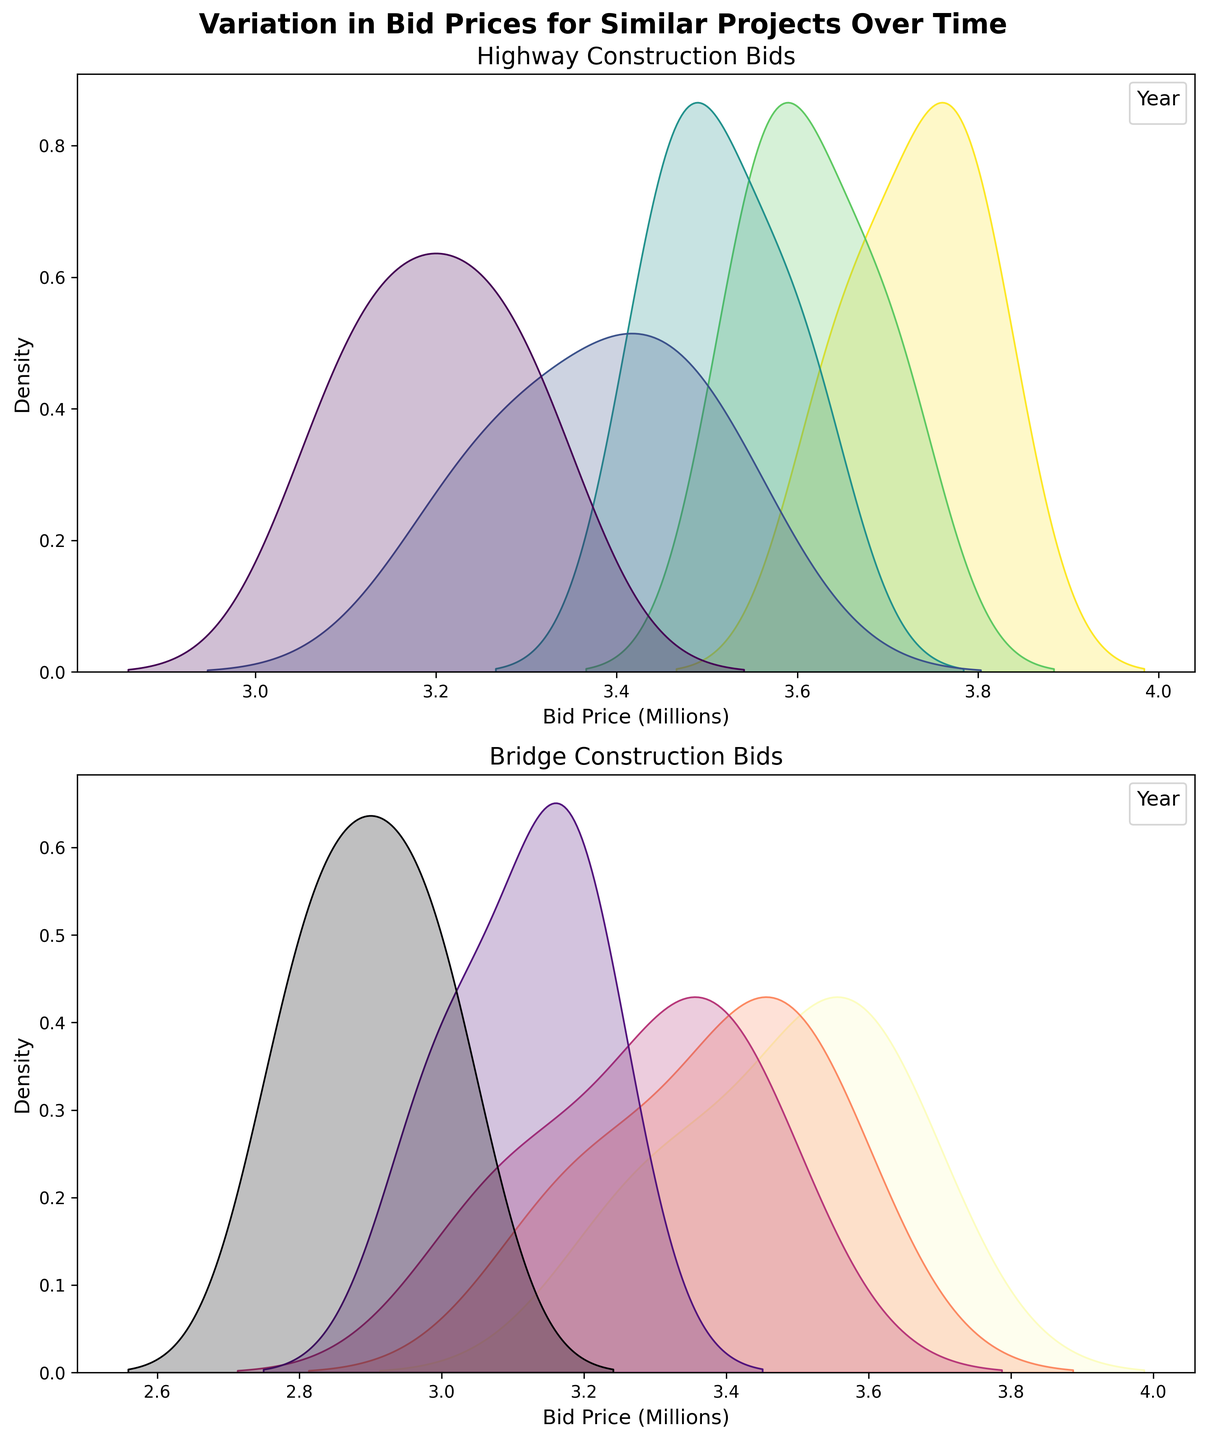How many unique years are represented in the Highway Construction bids plot? The legend in the Highway Construction bids plot shows each year represented by a different color or hue. Count the unique entries in the legend.
Answer: 5 How do the density curves for Highway Construction bids shift over the years? Observe the position of the peaks of the density plots over the years. If the peaks move to the right or become higher over time, the bid prices are increasing. The plot's x-axis represents bid prices in millions.
Answer: The peaks shift to the right Which year has the highest peak density for Bridge Construction bids? Examine the height of the density peaks of each year in the Bridge Construction bids plot. The year with the highest peak has the most frequent bid price.
Answer: 2022 Do the density plots for Highway Construction bids overlap significantly? Look at the extent to which the density plots for different years overlap on the Highway Construction plot. Significant overlap means the bid prices for those years are very similar.
Answer: Yes Which project type shows greater variation in bid prices over the years? Compare the width and spread of the density plots for both Highway Construction and Bridge Construction. Wider and more spread-out plots indicate greater variation in bid prices.
Answer: Bridge Construction What is the trend of bid prices for Highway Construction from 2018 to 2022? Analyze the peaks of the density plots for Highway Construction bids from 2018 to 2022. If the peaks move to the right over the years, it suggests an increasing trend in bid prices.
Answer: Increasing Are there any years where the bid prices for Bridge Construction and Highway Construction are similar? Compare the highest density bid price ranges (peaks) across both project types' plots for specific years. Similar bid price ranges indicate similarity.
Answer: Yes, around 2020 Which year shows the least variation in bid prices for Highway Construction? Identify the year with the narrowest density plot for Highway Construction bids. A narrow plot indicates less variation in bid prices.
Answer: 2020 Do the Bridge Construction bids show a higher density at lower bid prices compared to Highway Construction? Compare the density values at lower bid price ranges (left side of the x-axis) between the Bridge Construction and Highway Construction plots. Higher density values at lower prices indicate this trend.
Answer: Yes What can you infer about the bid prices for Acme Construction Inc. over the years for both project types? Trace Acme Construction Inc.'s bid prices from the data provided and check how these map onto the peaks of the density plots for both project types.
Answer: They are consistently competitive and increasing 